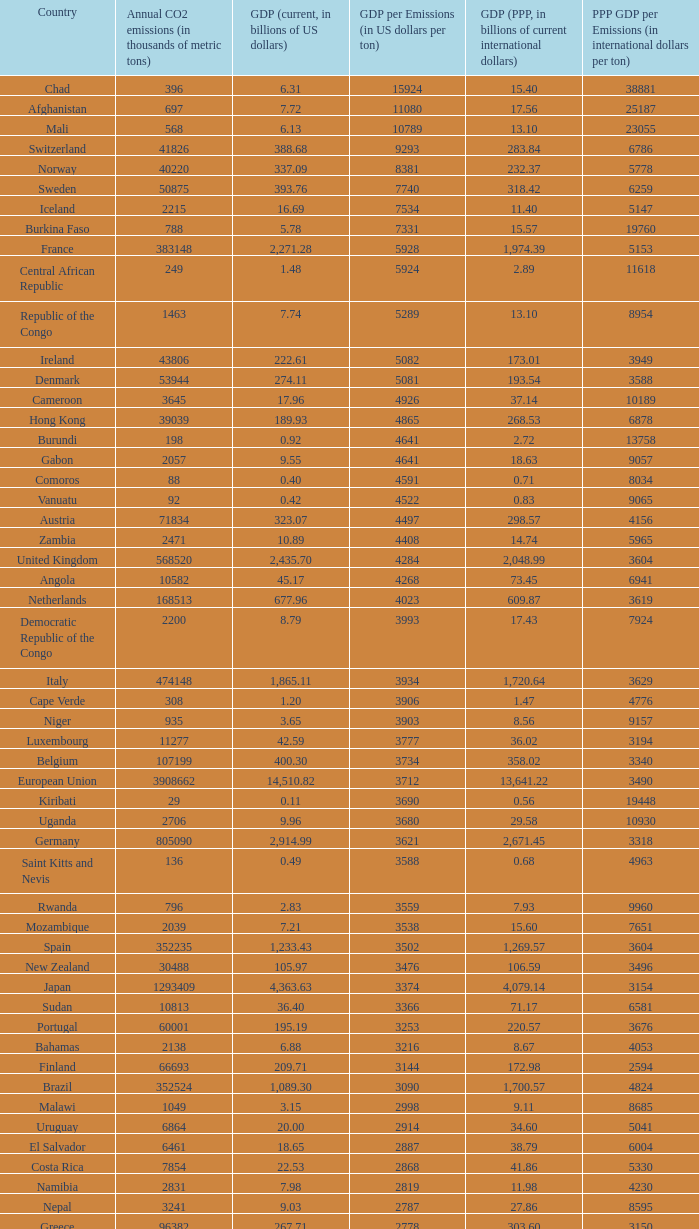When the annual co2 emissions (in thousands of metric tons) is 1811, what is the country? Haiti. 